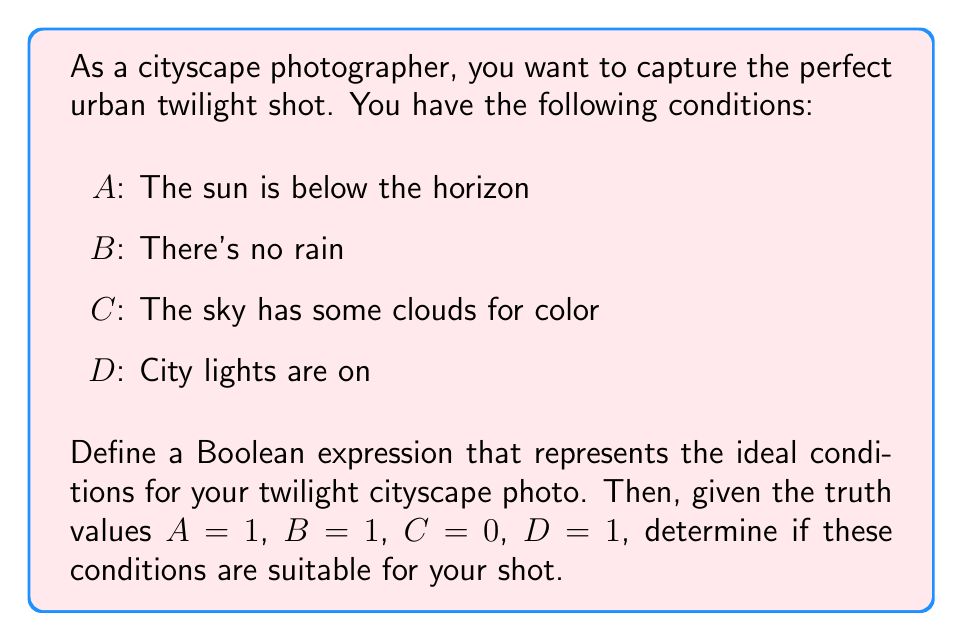Provide a solution to this math problem. 1) First, let's define our Boolean expression for ideal conditions:

   $$(A \land B \land C \land D)$$

   This expression means we want all conditions to be true (1) for the perfect shot.

2) Now, let's substitute the given truth values:

   $$(1 \land 1 \land 0 \land 1)$$

3) Evaluate the expression:
   - $1 \land 1 = 1$
   - $1 \land 0 = 0$
   - $0 \land 1 = 0$

   So, $(1 \land 1 \land 0 \land 1) = 0$

4) The result is 0 (false), which means these conditions are not ideal for the twilight cityscape photo.

5) The reason is that condition C (sky has some clouds for color) is false (0), while our ideal conditions require all factors to be true.
Answer: 0 (False) 